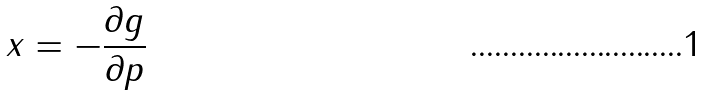<formula> <loc_0><loc_0><loc_500><loc_500>x = - \frac { \partial g } { \partial p }</formula> 